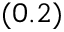<formula> <loc_0><loc_0><loc_500><loc_500>( 0 . 2 )</formula> 